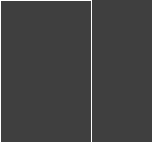Convert code to text. <code><loc_0><loc_0><loc_500><loc_500><_Lua_>

</code> 